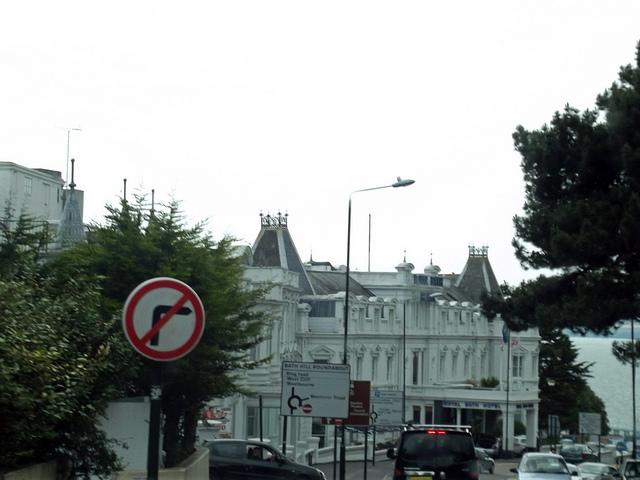What pedal does the driver of the black van have their foot on? brake 